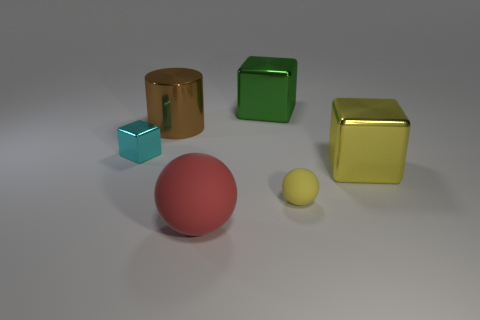Subtract all large blocks. How many blocks are left? 1 Subtract all balls. How many objects are left? 4 Add 3 big green metallic cubes. How many big green metallic cubes exist? 4 Add 4 large objects. How many objects exist? 10 Subtract all red spheres. How many spheres are left? 1 Subtract 0 blue cubes. How many objects are left? 6 Subtract 1 cubes. How many cubes are left? 2 Subtract all yellow cubes. Subtract all gray balls. How many cubes are left? 2 Subtract all green cubes. How many gray cylinders are left? 0 Subtract all large purple rubber blocks. Subtract all cyan cubes. How many objects are left? 5 